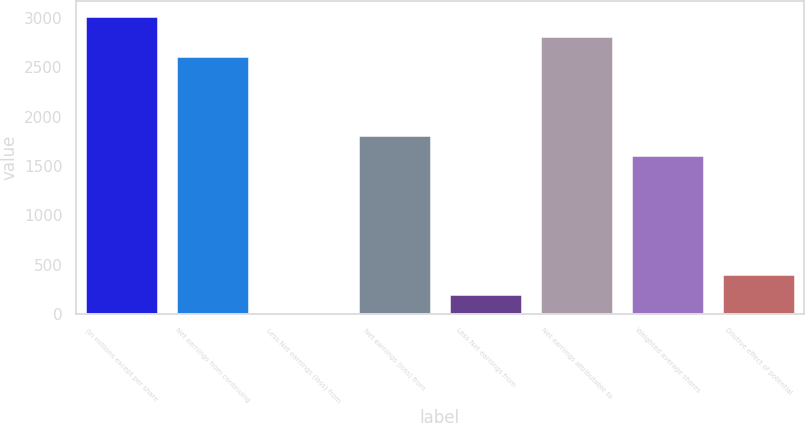<chart> <loc_0><loc_0><loc_500><loc_500><bar_chart><fcel>(In millions except per share<fcel>Net earnings from continuing<fcel>Less Net earnings (loss) from<fcel>Net earnings (loss) from<fcel>Less Net earnings from<fcel>Net earnings attributable to<fcel>Weighted average shares<fcel>Dilutive effect of potential<nl><fcel>3022.4<fcel>2619.44<fcel>0.2<fcel>1813.52<fcel>201.68<fcel>2820.92<fcel>1612.04<fcel>403.16<nl></chart> 